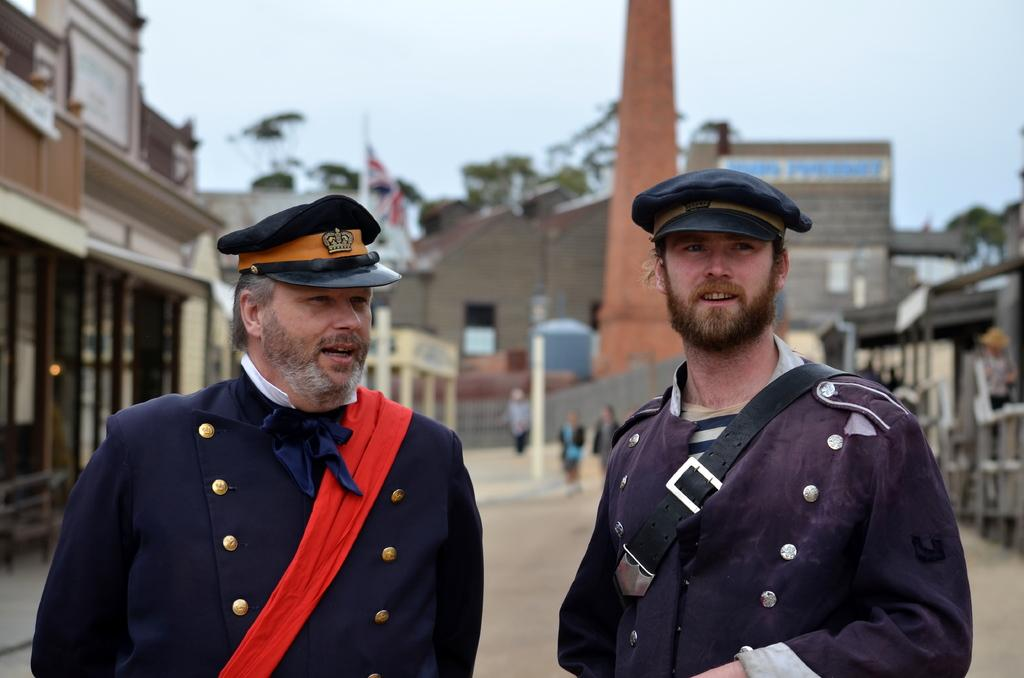Who or what can be seen in the image? There are people in the image. What structures are present in the image? There are buildings in the image. What are the tall, thin objects in the image? There are poles in the image. What can be seen beneath the people and buildings? The ground is visible in the image. What is located on the right side of the image? There are objects on the right side of the image. What is the symbolic object in the image? There is a flag in the image. What is visible above the people, buildings, and objects? The sky is visible in the image. What type of condition is the pocket experiencing in the image? There is no pocket present in the image, so it is not possible to determine the condition it might be experiencing. What is the jar used for in the image? There is no jar present in the image, so it is not possible to determine its purpose or use. 